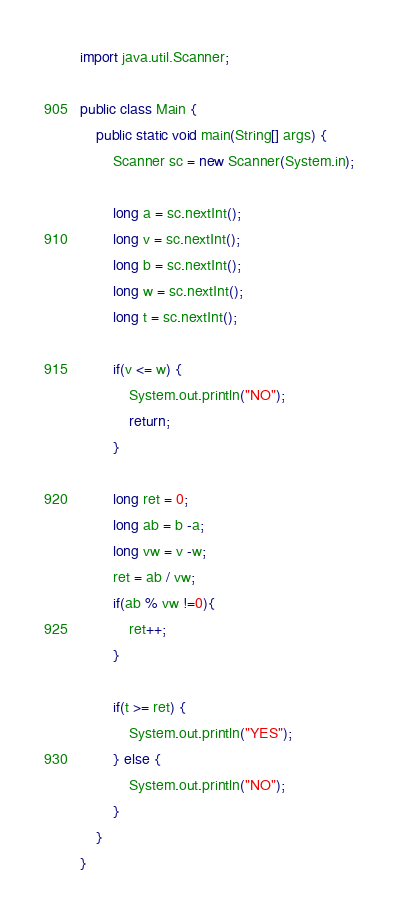Convert code to text. <code><loc_0><loc_0><loc_500><loc_500><_Java_>import java.util.Scanner;

public class Main {
    public static void main(String[] args) {
        Scanner sc = new Scanner(System.in);

        long a = sc.nextInt();
        long v = sc.nextInt();
        long b = sc.nextInt();
        long w = sc.nextInt();
        long t = sc.nextInt();

        if(v <= w) {
            System.out.println("NO");
            return;
        }

        long ret = 0;
        long ab = b -a;
        long vw = v -w;
        ret = ab / vw;
        if(ab % vw !=0){
            ret++;
        }

        if(t >= ret) {
            System.out.println("YES");
        } else {
            System.out.println("NO");
        }
    }
}
</code> 